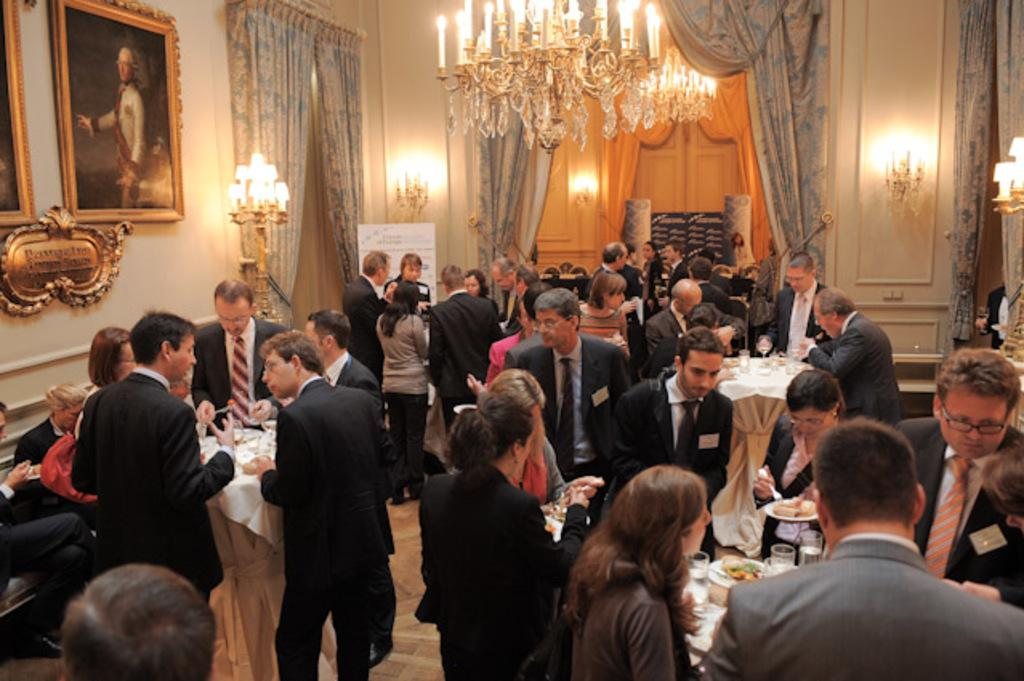How many groups of people can be seen in the image? There are people in the image, and they are in groups. What are the people doing at the tables? The people are standing at tables. What activity are the people engaged in? The people are talking among themselves. What type of event is taking place in the image? The setting is a party. What type of dinosaur can be seen in the image? There are no dinosaurs present in the image. Can you solve the riddle that is being discussed among the people in the image? There is no riddle mentioned or visible in the image. 